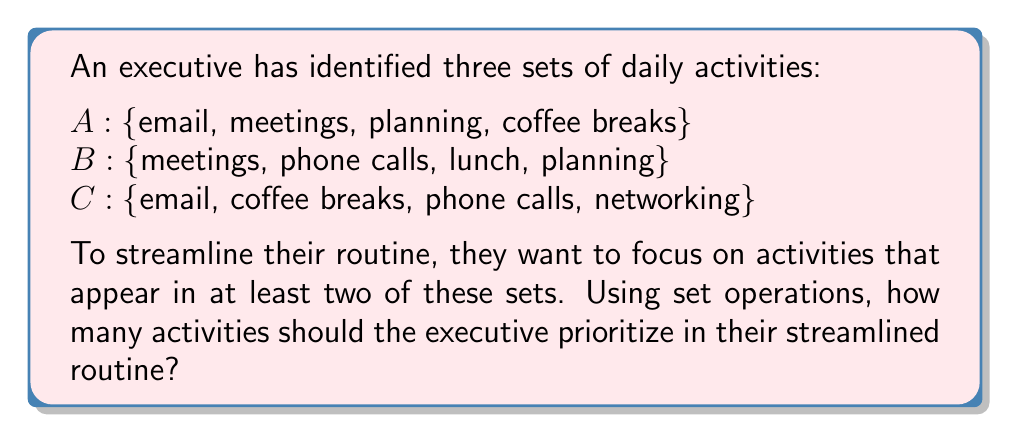Solve this math problem. To solve this problem, we need to find the number of elements in the union of the pairwise intersections of the sets A, B, and C. This can be represented mathematically as:

$$(A \cap B) \cup (B \cap C) \cup (A \cap C)$$

Let's break this down step-by-step:

1. Find the pairwise intersections:
   $A \cap B = \text{\{meetings, planning\}}$
   $B \cap C = \text{\{phone calls\}}$
   $A \cap C = \text{\{email, coffee breaks\}}$

2. Take the union of these intersections:
   $(A \cap B) \cup (B \cap C) \cup (A \cap C) = \text{\{meetings, planning, phone calls, email, coffee breaks\}}$

3. Count the number of elements in this final set:
   $|\text{\{meetings, planning, phone calls, email, coffee breaks\}}| = 5$

Therefore, the executive should prioritize 5 activities in their streamlined routine.

This approach ensures that the executive focuses on activities that are important enough to appear in at least two of their original sets, effectively eliminating redundant or less crucial tasks.
Answer: 5 activities 